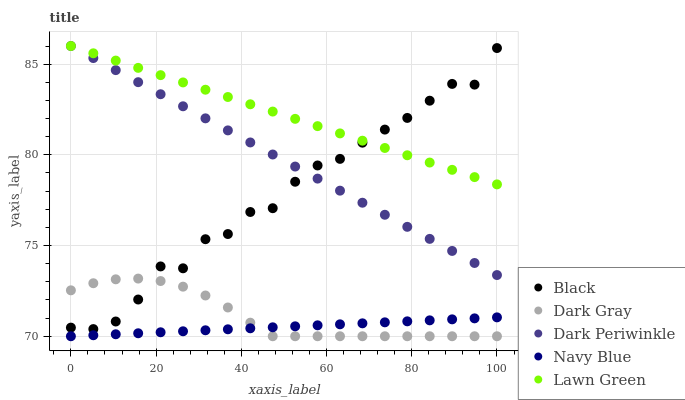Does Navy Blue have the minimum area under the curve?
Answer yes or no. Yes. Does Lawn Green have the maximum area under the curve?
Answer yes or no. Yes. Does Black have the minimum area under the curve?
Answer yes or no. No. Does Black have the maximum area under the curve?
Answer yes or no. No. Is Dark Periwinkle the smoothest?
Answer yes or no. Yes. Is Black the roughest?
Answer yes or no. Yes. Is Navy Blue the smoothest?
Answer yes or no. No. Is Navy Blue the roughest?
Answer yes or no. No. Does Dark Gray have the lowest value?
Answer yes or no. Yes. Does Black have the lowest value?
Answer yes or no. No. Does Lawn Green have the highest value?
Answer yes or no. Yes. Does Black have the highest value?
Answer yes or no. No. Is Navy Blue less than Black?
Answer yes or no. Yes. Is Dark Periwinkle greater than Navy Blue?
Answer yes or no. Yes. Does Black intersect Dark Gray?
Answer yes or no. Yes. Is Black less than Dark Gray?
Answer yes or no. No. Is Black greater than Dark Gray?
Answer yes or no. No. Does Navy Blue intersect Black?
Answer yes or no. No. 